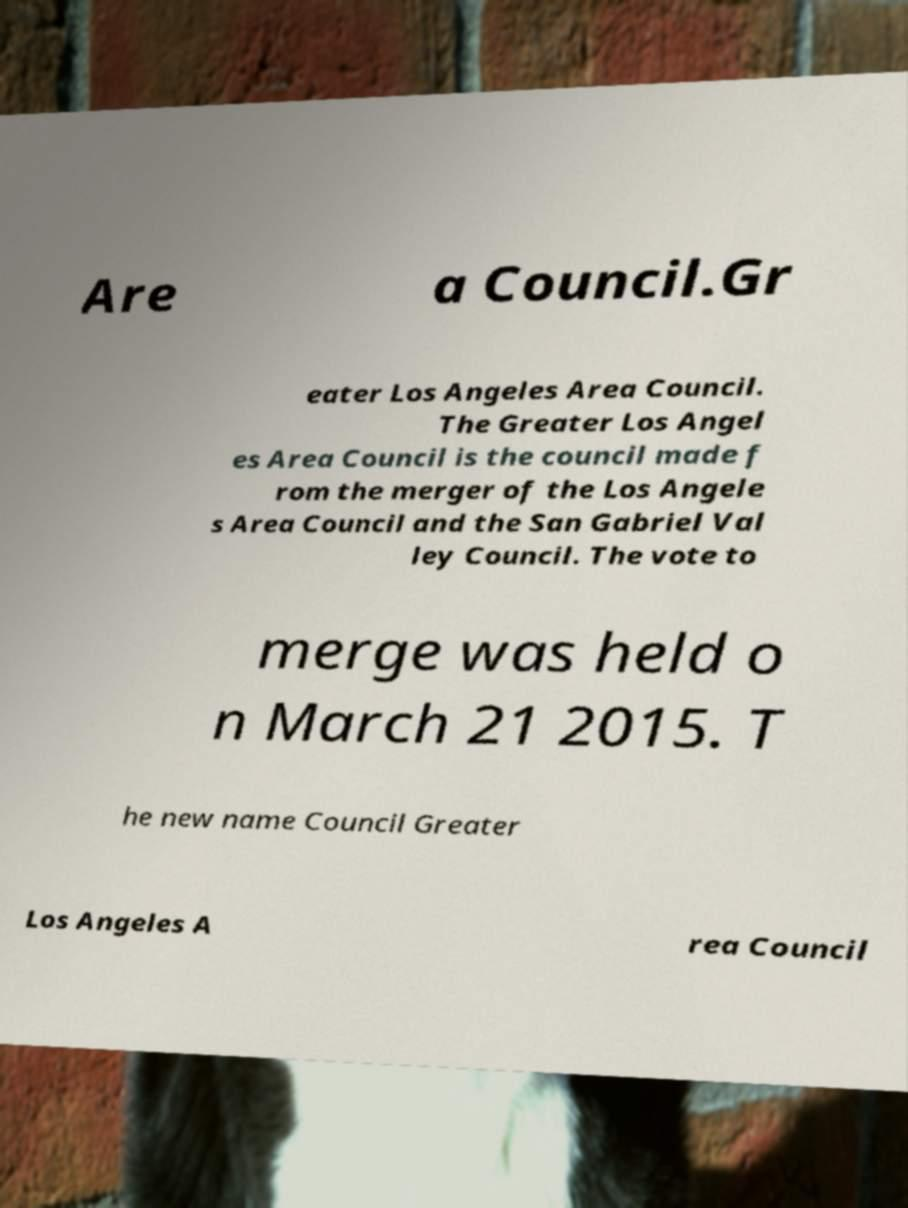I need the written content from this picture converted into text. Can you do that? Are a Council.Gr eater Los Angeles Area Council. The Greater Los Angel es Area Council is the council made f rom the merger of the Los Angele s Area Council and the San Gabriel Val ley Council. The vote to merge was held o n March 21 2015. T he new name Council Greater Los Angeles A rea Council 